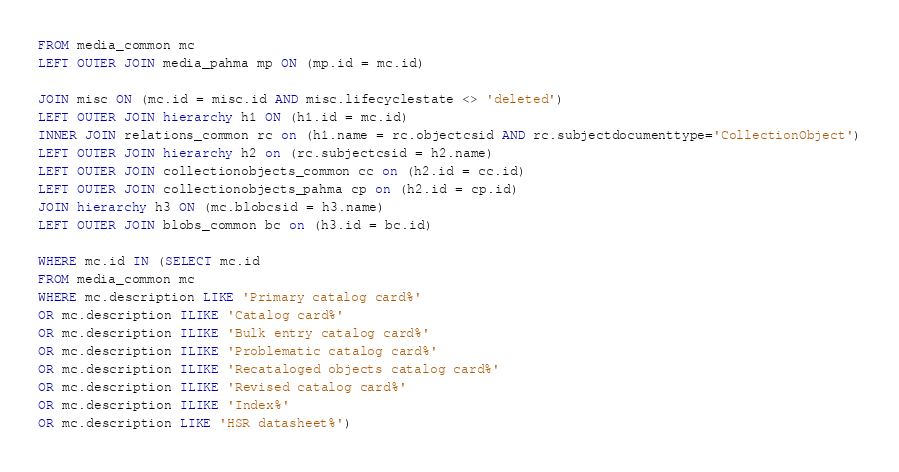Convert code to text. <code><loc_0><loc_0><loc_500><loc_500><_SQL_>FROM media_common mc
LEFT OUTER JOIN media_pahma mp ON (mp.id = mc.id)

JOIN misc ON (mc.id = misc.id AND misc.lifecyclestate <> 'deleted')
LEFT OUTER JOIN hierarchy h1 ON (h1.id = mc.id)
INNER JOIN relations_common rc on (h1.name = rc.objectcsid AND rc.subjectdocumenttype='CollectionObject')
LEFT OUTER JOIN hierarchy h2 on (rc.subjectcsid = h2.name)
LEFT OUTER JOIN collectionobjects_common cc on (h2.id = cc.id)
LEFT OUTER JOIN collectionobjects_pahma cp on (h2.id = cp.id)
JOIN hierarchy h3 ON (mc.blobcsid = h3.name)
LEFT OUTER JOIN blobs_common bc on (h3.id = bc.id)

WHERE mc.id IN (SELECT mc.id
FROM media_common mc
WHERE mc.description LIKE 'Primary catalog card%'
OR mc.description ILIKE 'Catalog card%'
OR mc.description ILIKE 'Bulk entry catalog card%'
OR mc.description ILIKE 'Problematic catalog card%'
OR mc.description ILIKE 'Recataloged objects catalog card%'
OR mc.description ILIKE 'Revised catalog card%'
OR mc.description ILIKE 'Index%'
OR mc.description LIKE 'HSR datasheet%')
</code> 